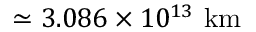Convert formula to latex. <formula><loc_0><loc_0><loc_500><loc_500>\simeq 3 . 0 8 6 \times 1 0 ^ { 1 3 } \ k m</formula> 